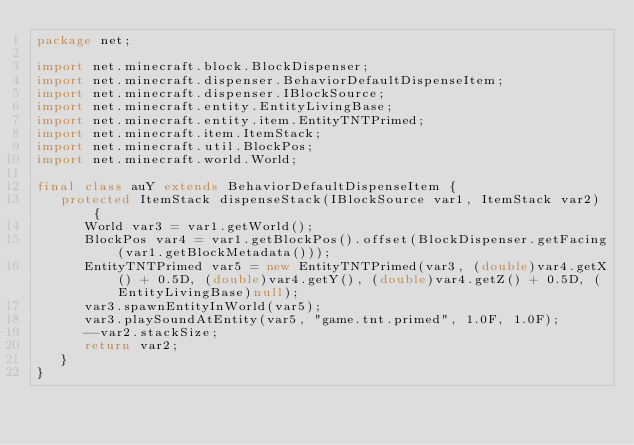Convert code to text. <code><loc_0><loc_0><loc_500><loc_500><_Java_>package net;

import net.minecraft.block.BlockDispenser;
import net.minecraft.dispenser.BehaviorDefaultDispenseItem;
import net.minecraft.dispenser.IBlockSource;
import net.minecraft.entity.EntityLivingBase;
import net.minecraft.entity.item.EntityTNTPrimed;
import net.minecraft.item.ItemStack;
import net.minecraft.util.BlockPos;
import net.minecraft.world.World;

final class auY extends BehaviorDefaultDispenseItem {
   protected ItemStack dispenseStack(IBlockSource var1, ItemStack var2) {
      World var3 = var1.getWorld();
      BlockPos var4 = var1.getBlockPos().offset(BlockDispenser.getFacing(var1.getBlockMetadata()));
      EntityTNTPrimed var5 = new EntityTNTPrimed(var3, (double)var4.getX() + 0.5D, (double)var4.getY(), (double)var4.getZ() + 0.5D, (EntityLivingBase)null);
      var3.spawnEntityInWorld(var5);
      var3.playSoundAtEntity(var5, "game.tnt.primed", 1.0F, 1.0F);
      --var2.stackSize;
      return var2;
   }
}
</code> 